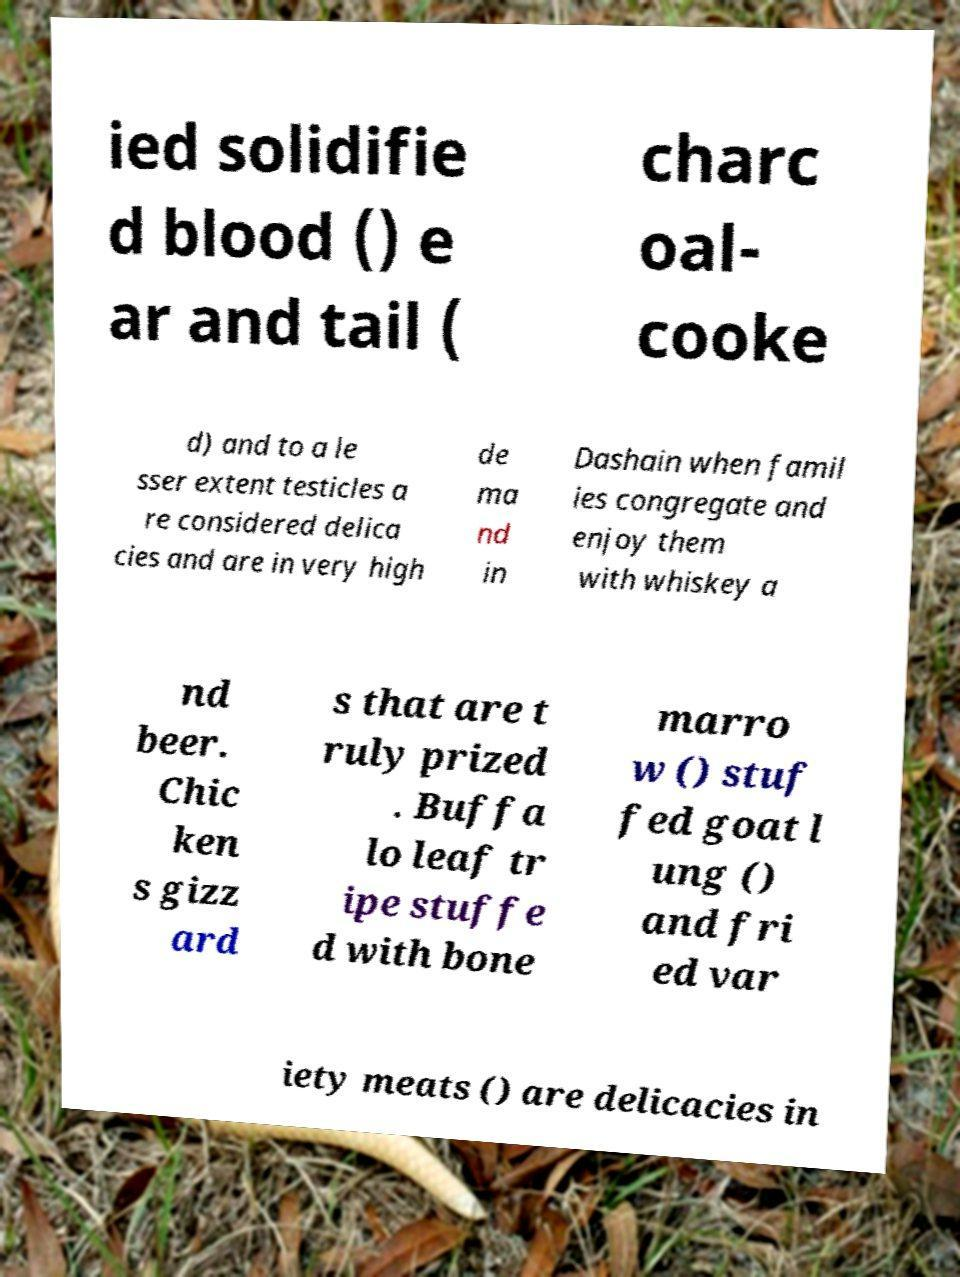Could you assist in decoding the text presented in this image and type it out clearly? ied solidifie d blood () e ar and tail ( charc oal- cooke d) and to a le sser extent testicles a re considered delica cies and are in very high de ma nd in Dashain when famil ies congregate and enjoy them with whiskey a nd beer. Chic ken s gizz ard s that are t ruly prized . Buffa lo leaf tr ipe stuffe d with bone marro w () stuf fed goat l ung () and fri ed var iety meats () are delicacies in 